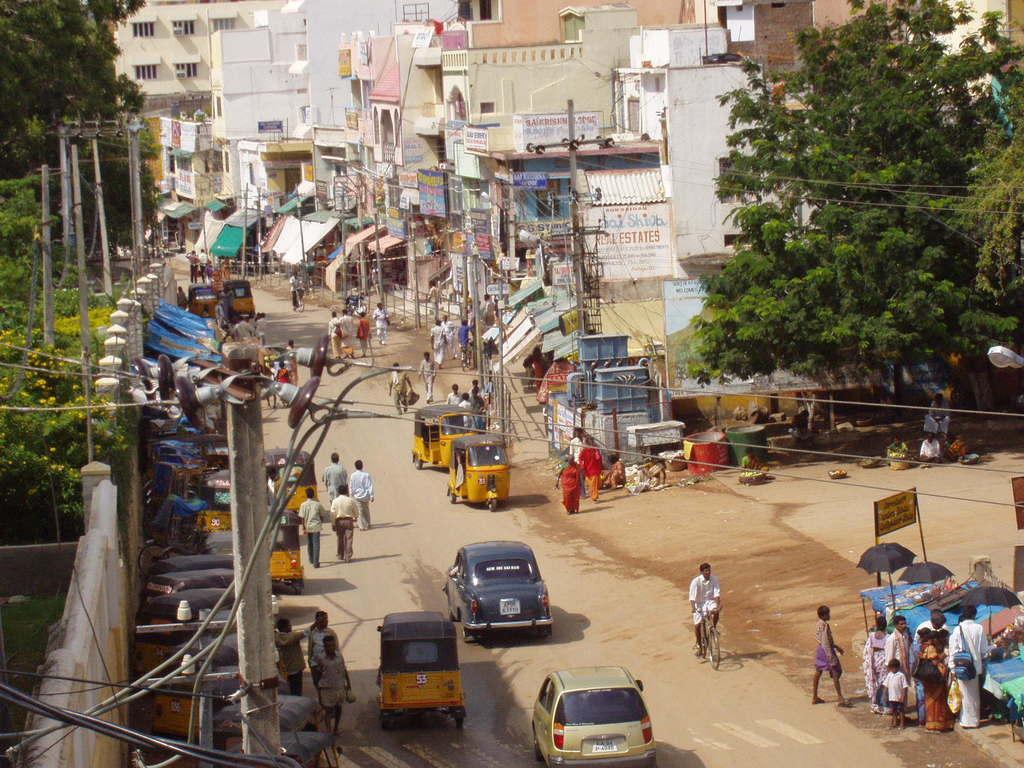Could you give a brief overview of what you see in this image? In this image we can see buildings, stalls, sheds, name boards, advertisements on the walls, electric poles, electric cables, trees, bins, transformer, street vendors, motor vehicles on the road and persons walking on the road. 